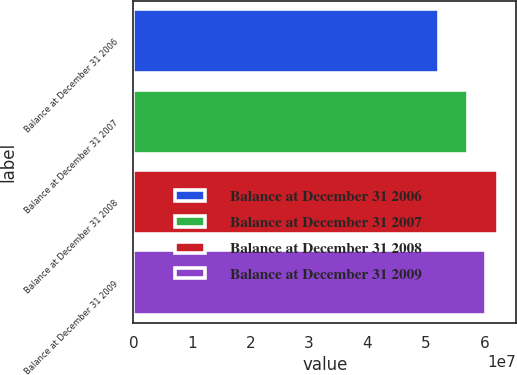<chart> <loc_0><loc_0><loc_500><loc_500><bar_chart><fcel>Balance at December 31 2006<fcel>Balance at December 31 2007<fcel>Balance at December 31 2008<fcel>Balance at December 31 2009<nl><fcel>5.21696e+07<fcel>5.72027e+07<fcel>6.23536e+07<fcel>6.03567e+07<nl></chart> 